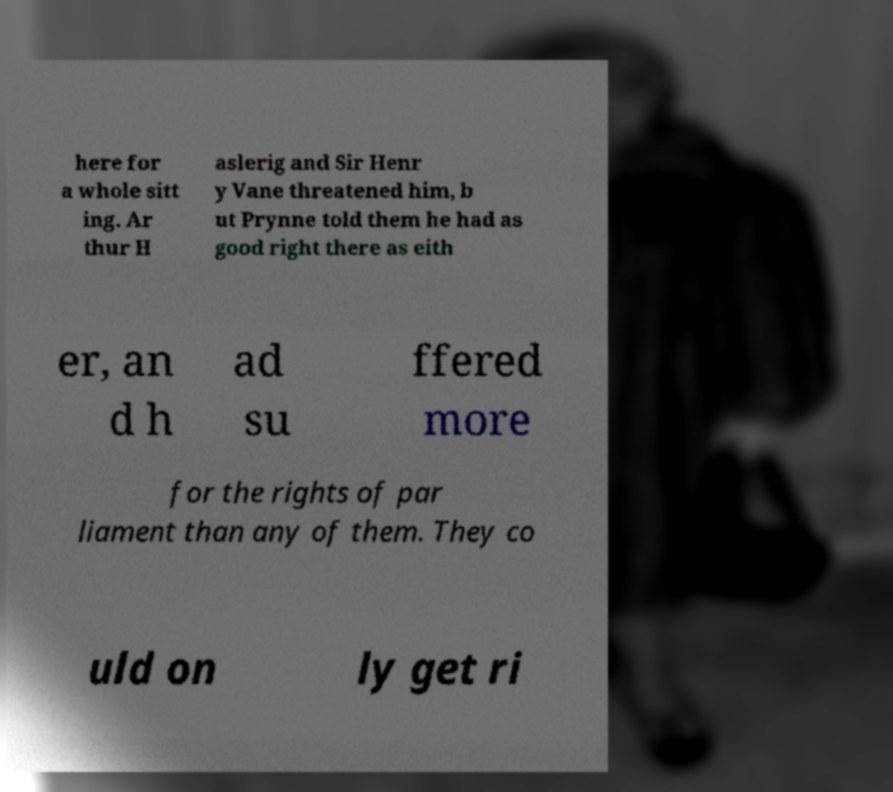I need the written content from this picture converted into text. Can you do that? here for a whole sitt ing. Ar thur H aslerig and Sir Henr y Vane threatened him, b ut Prynne told them he had as good right there as eith er, an d h ad su ffered more for the rights of par liament than any of them. They co uld on ly get ri 